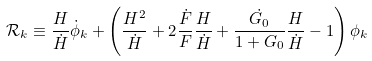<formula> <loc_0><loc_0><loc_500><loc_500>\mathcal { R } _ { k } \equiv \frac { H } { \dot { H } } \dot { \phi } _ { k } + \left ( \frac { H ^ { 2 } } { \dot { H } } + 2 \frac { \dot { F } } { F } \frac { H } { \dot { H } } + \frac { \dot { G _ { 0 } } } { 1 + G _ { 0 } } \frac { H } { \dot { H } } - 1 \right ) \phi _ { k }</formula> 